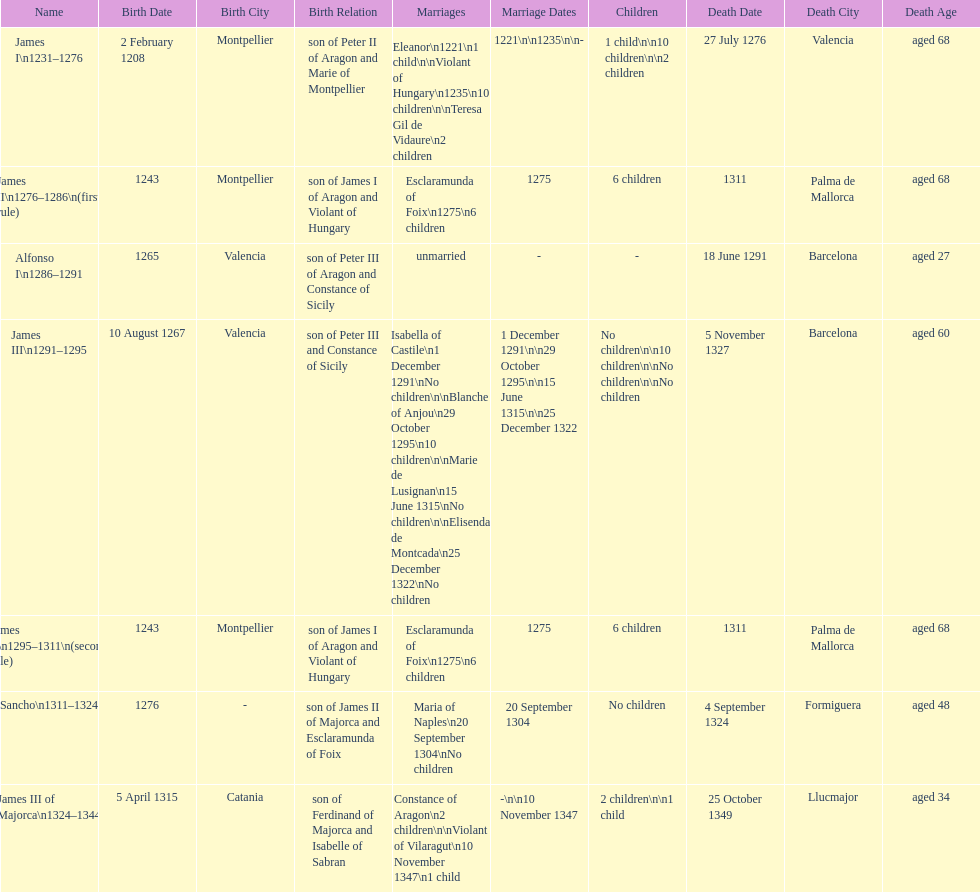How many total marriages did james i have? 3. 